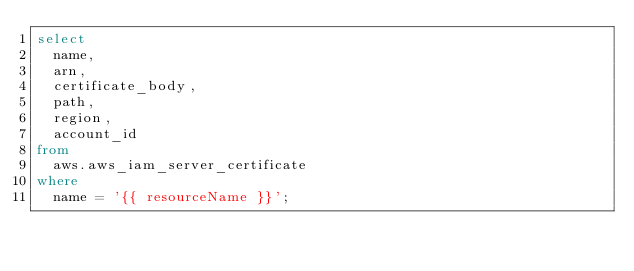Convert code to text. <code><loc_0><loc_0><loc_500><loc_500><_SQL_>select 
  name, 
  arn, 
  certificate_body,
  path,
  region,
  account_id
from 
  aws.aws_iam_server_certificate
where 
  name = '{{ resourceName }}';
</code> 